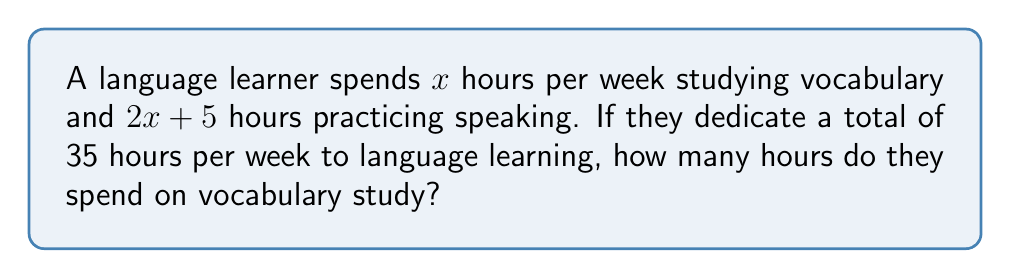Show me your answer to this math problem. 1. Let's define our variables:
   $x$ = hours spent on vocabulary study
   $2x + 5$ = hours spent on speaking practice

2. We know that the total time spent is 35 hours, so we can set up the equation:
   $x + (2x + 5) = 35$

3. Simplify the left side of the equation:
   $3x + 5 = 35$

4. Subtract 5 from both sides:
   $3x = 30$

5. Divide both sides by 3:
   $x = 10$

Therefore, the language learner spends 10 hours per week on vocabulary study.
Answer: 10 hours 